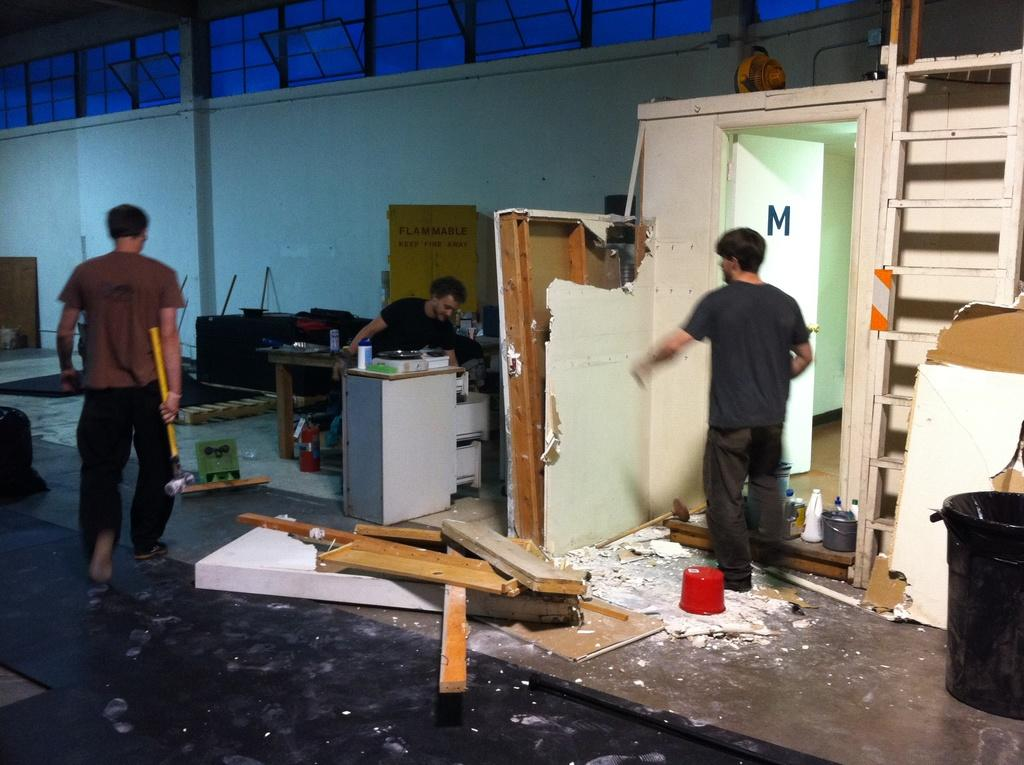What is the setting of the image? There is a room in the image. How many people are present in the image? There are three people in the image. What is one person doing in the image? One person is walking and holding a hammer. What can be seen in the background of the room? There is a wooden board, a wall, a door, and a table in the background. What type of scarecrow is standing near the door in the image? There is no scarecrow present in the image. What role does the government play in the activities depicted in the image? The image does not depict any government involvement or activities. 